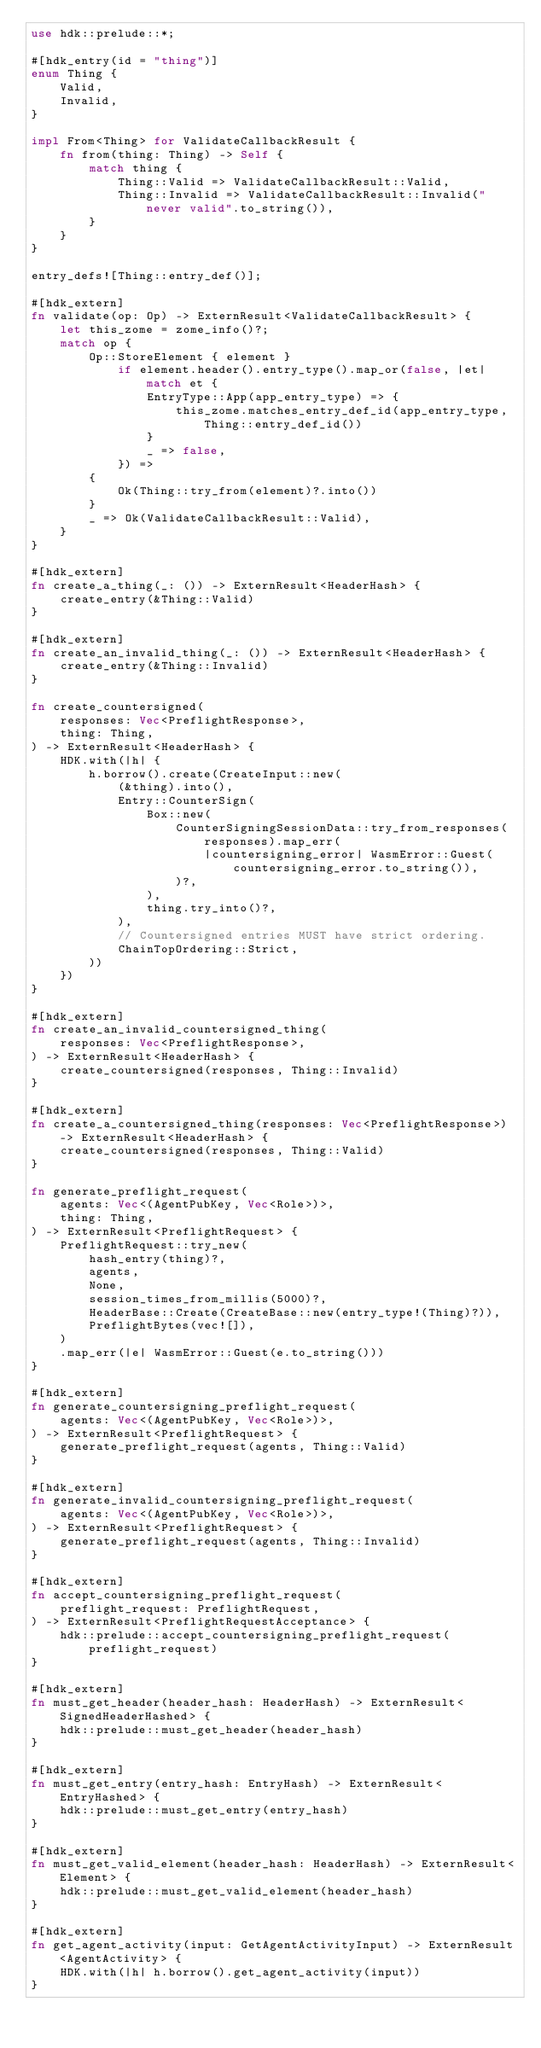Convert code to text. <code><loc_0><loc_0><loc_500><loc_500><_Rust_>use hdk::prelude::*;

#[hdk_entry(id = "thing")]
enum Thing {
    Valid,
    Invalid,
}

impl From<Thing> for ValidateCallbackResult {
    fn from(thing: Thing) -> Self {
        match thing {
            Thing::Valid => ValidateCallbackResult::Valid,
            Thing::Invalid => ValidateCallbackResult::Invalid("never valid".to_string()),
        }
    }
}

entry_defs![Thing::entry_def()];

#[hdk_extern]
fn validate(op: Op) -> ExternResult<ValidateCallbackResult> {
    let this_zome = zome_info()?;
    match op {
        Op::StoreElement { element }
            if element.header().entry_type().map_or(false, |et| match et {
                EntryType::App(app_entry_type) => {
                    this_zome.matches_entry_def_id(app_entry_type, Thing::entry_def_id())
                }
                _ => false,
            }) =>
        {
            Ok(Thing::try_from(element)?.into())
        }
        _ => Ok(ValidateCallbackResult::Valid),
    }
}

#[hdk_extern]
fn create_a_thing(_: ()) -> ExternResult<HeaderHash> {
    create_entry(&Thing::Valid)
}

#[hdk_extern]
fn create_an_invalid_thing(_: ()) -> ExternResult<HeaderHash> {
    create_entry(&Thing::Invalid)
}

fn create_countersigned(
    responses: Vec<PreflightResponse>,
    thing: Thing,
) -> ExternResult<HeaderHash> {
    HDK.with(|h| {
        h.borrow().create(CreateInput::new(
            (&thing).into(),
            Entry::CounterSign(
                Box::new(
                    CounterSigningSessionData::try_from_responses(responses).map_err(
                        |countersigning_error| WasmError::Guest(countersigning_error.to_string()),
                    )?,
                ),
                thing.try_into()?,
            ),
            // Countersigned entries MUST have strict ordering.
            ChainTopOrdering::Strict,
        ))
    })
}

#[hdk_extern]
fn create_an_invalid_countersigned_thing(
    responses: Vec<PreflightResponse>,
) -> ExternResult<HeaderHash> {
    create_countersigned(responses, Thing::Invalid)
}

#[hdk_extern]
fn create_a_countersigned_thing(responses: Vec<PreflightResponse>) -> ExternResult<HeaderHash> {
    create_countersigned(responses, Thing::Valid)
}

fn generate_preflight_request(
    agents: Vec<(AgentPubKey, Vec<Role>)>,
    thing: Thing,
) -> ExternResult<PreflightRequest> {
    PreflightRequest::try_new(
        hash_entry(thing)?,
        agents,
        None,
        session_times_from_millis(5000)?,
        HeaderBase::Create(CreateBase::new(entry_type!(Thing)?)),
        PreflightBytes(vec![]),
    )
    .map_err(|e| WasmError::Guest(e.to_string()))
}

#[hdk_extern]
fn generate_countersigning_preflight_request(
    agents: Vec<(AgentPubKey, Vec<Role>)>,
) -> ExternResult<PreflightRequest> {
    generate_preflight_request(agents, Thing::Valid)
}

#[hdk_extern]
fn generate_invalid_countersigning_preflight_request(
    agents: Vec<(AgentPubKey, Vec<Role>)>,
) -> ExternResult<PreflightRequest> {
    generate_preflight_request(agents, Thing::Invalid)
}

#[hdk_extern]
fn accept_countersigning_preflight_request(
    preflight_request: PreflightRequest,
) -> ExternResult<PreflightRequestAcceptance> {
    hdk::prelude::accept_countersigning_preflight_request(preflight_request)
}

#[hdk_extern]
fn must_get_header(header_hash: HeaderHash) -> ExternResult<SignedHeaderHashed> {
    hdk::prelude::must_get_header(header_hash)
}

#[hdk_extern]
fn must_get_entry(entry_hash: EntryHash) -> ExternResult<EntryHashed> {
    hdk::prelude::must_get_entry(entry_hash)
}

#[hdk_extern]
fn must_get_valid_element(header_hash: HeaderHash) -> ExternResult<Element> {
    hdk::prelude::must_get_valid_element(header_hash)
}

#[hdk_extern]
fn get_agent_activity(input: GetAgentActivityInput) -> ExternResult<AgentActivity> {
    HDK.with(|h| h.borrow().get_agent_activity(input))
}
</code> 